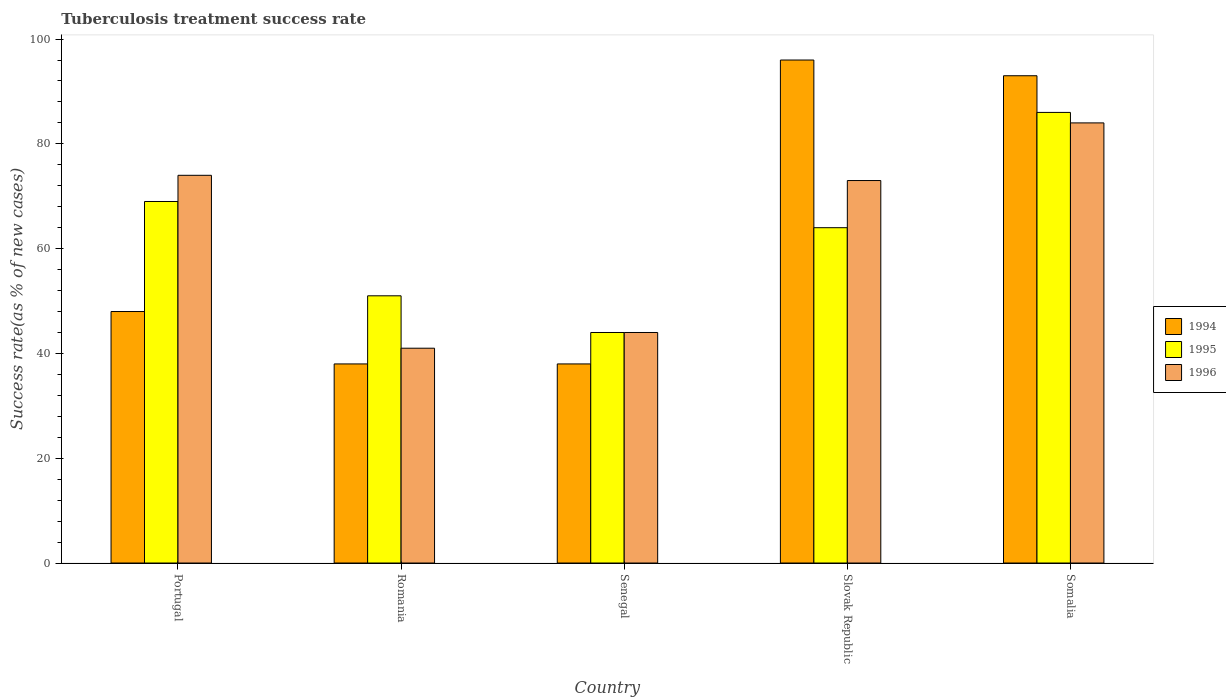What is the label of the 5th group of bars from the left?
Provide a short and direct response. Somalia. Across all countries, what is the maximum tuberculosis treatment success rate in 1994?
Make the answer very short. 96. Across all countries, what is the minimum tuberculosis treatment success rate in 1994?
Your answer should be very brief. 38. In which country was the tuberculosis treatment success rate in 1994 maximum?
Your answer should be compact. Slovak Republic. In which country was the tuberculosis treatment success rate in 1994 minimum?
Keep it short and to the point. Romania. What is the total tuberculosis treatment success rate in 1994 in the graph?
Make the answer very short. 313. What is the average tuberculosis treatment success rate in 1995 per country?
Your answer should be compact. 62.8. What is the difference between the tuberculosis treatment success rate of/in 1995 and tuberculosis treatment success rate of/in 1994 in Slovak Republic?
Offer a terse response. -32. What is the ratio of the tuberculosis treatment success rate in 1995 in Romania to that in Somalia?
Provide a succinct answer. 0.59. Is the tuberculosis treatment success rate in 1996 in Portugal less than that in Senegal?
Provide a short and direct response. No. What is the difference between the highest and the second highest tuberculosis treatment success rate in 1995?
Keep it short and to the point. -5. What is the difference between the highest and the lowest tuberculosis treatment success rate in 1994?
Offer a terse response. 58. Is the sum of the tuberculosis treatment success rate in 1995 in Portugal and Senegal greater than the maximum tuberculosis treatment success rate in 1996 across all countries?
Provide a short and direct response. Yes. What does the 3rd bar from the left in Senegal represents?
Your answer should be compact. 1996. What does the 3rd bar from the right in Romania represents?
Provide a short and direct response. 1994. How many countries are there in the graph?
Give a very brief answer. 5. Does the graph contain any zero values?
Provide a short and direct response. No. Where does the legend appear in the graph?
Provide a succinct answer. Center right. How many legend labels are there?
Provide a short and direct response. 3. What is the title of the graph?
Your response must be concise. Tuberculosis treatment success rate. Does "1968" appear as one of the legend labels in the graph?
Make the answer very short. No. What is the label or title of the X-axis?
Provide a short and direct response. Country. What is the label or title of the Y-axis?
Provide a short and direct response. Success rate(as % of new cases). What is the Success rate(as % of new cases) in 1994 in Portugal?
Provide a succinct answer. 48. What is the Success rate(as % of new cases) of 1994 in Romania?
Your answer should be very brief. 38. What is the Success rate(as % of new cases) of 1996 in Romania?
Your response must be concise. 41. What is the Success rate(as % of new cases) in 1995 in Senegal?
Offer a terse response. 44. What is the Success rate(as % of new cases) in 1996 in Senegal?
Offer a very short reply. 44. What is the Success rate(as % of new cases) in 1994 in Slovak Republic?
Keep it short and to the point. 96. What is the Success rate(as % of new cases) in 1994 in Somalia?
Provide a short and direct response. 93. What is the Success rate(as % of new cases) in 1996 in Somalia?
Provide a succinct answer. 84. Across all countries, what is the maximum Success rate(as % of new cases) of 1994?
Offer a terse response. 96. Across all countries, what is the minimum Success rate(as % of new cases) of 1995?
Give a very brief answer. 44. What is the total Success rate(as % of new cases) in 1994 in the graph?
Offer a very short reply. 313. What is the total Success rate(as % of new cases) in 1995 in the graph?
Give a very brief answer. 314. What is the total Success rate(as % of new cases) in 1996 in the graph?
Offer a very short reply. 316. What is the difference between the Success rate(as % of new cases) of 1994 in Portugal and that in Romania?
Provide a short and direct response. 10. What is the difference between the Success rate(as % of new cases) in 1996 in Portugal and that in Romania?
Make the answer very short. 33. What is the difference between the Success rate(as % of new cases) of 1994 in Portugal and that in Senegal?
Provide a short and direct response. 10. What is the difference between the Success rate(as % of new cases) of 1994 in Portugal and that in Slovak Republic?
Offer a terse response. -48. What is the difference between the Success rate(as % of new cases) in 1995 in Portugal and that in Slovak Republic?
Offer a very short reply. 5. What is the difference between the Success rate(as % of new cases) of 1994 in Portugal and that in Somalia?
Ensure brevity in your answer.  -45. What is the difference between the Success rate(as % of new cases) in 1995 in Portugal and that in Somalia?
Ensure brevity in your answer.  -17. What is the difference between the Success rate(as % of new cases) in 1994 in Romania and that in Senegal?
Provide a succinct answer. 0. What is the difference between the Success rate(as % of new cases) of 1995 in Romania and that in Senegal?
Keep it short and to the point. 7. What is the difference between the Success rate(as % of new cases) in 1994 in Romania and that in Slovak Republic?
Keep it short and to the point. -58. What is the difference between the Success rate(as % of new cases) of 1995 in Romania and that in Slovak Republic?
Your answer should be very brief. -13. What is the difference between the Success rate(as % of new cases) of 1996 in Romania and that in Slovak Republic?
Your response must be concise. -32. What is the difference between the Success rate(as % of new cases) of 1994 in Romania and that in Somalia?
Provide a succinct answer. -55. What is the difference between the Success rate(as % of new cases) of 1995 in Romania and that in Somalia?
Make the answer very short. -35. What is the difference between the Success rate(as % of new cases) of 1996 in Romania and that in Somalia?
Provide a short and direct response. -43. What is the difference between the Success rate(as % of new cases) in 1994 in Senegal and that in Slovak Republic?
Offer a terse response. -58. What is the difference between the Success rate(as % of new cases) in 1995 in Senegal and that in Slovak Republic?
Offer a very short reply. -20. What is the difference between the Success rate(as % of new cases) in 1996 in Senegal and that in Slovak Republic?
Provide a short and direct response. -29. What is the difference between the Success rate(as % of new cases) of 1994 in Senegal and that in Somalia?
Provide a succinct answer. -55. What is the difference between the Success rate(as % of new cases) of 1995 in Senegal and that in Somalia?
Make the answer very short. -42. What is the difference between the Success rate(as % of new cases) of 1996 in Senegal and that in Somalia?
Offer a very short reply. -40. What is the difference between the Success rate(as % of new cases) in 1996 in Slovak Republic and that in Somalia?
Offer a terse response. -11. What is the difference between the Success rate(as % of new cases) of 1994 in Portugal and the Success rate(as % of new cases) of 1995 in Romania?
Your answer should be compact. -3. What is the difference between the Success rate(as % of new cases) in 1994 in Portugal and the Success rate(as % of new cases) in 1995 in Senegal?
Provide a succinct answer. 4. What is the difference between the Success rate(as % of new cases) in 1994 in Portugal and the Success rate(as % of new cases) in 1996 in Senegal?
Your answer should be very brief. 4. What is the difference between the Success rate(as % of new cases) of 1995 in Portugal and the Success rate(as % of new cases) of 1996 in Senegal?
Make the answer very short. 25. What is the difference between the Success rate(as % of new cases) in 1995 in Portugal and the Success rate(as % of new cases) in 1996 in Slovak Republic?
Ensure brevity in your answer.  -4. What is the difference between the Success rate(as % of new cases) in 1994 in Portugal and the Success rate(as % of new cases) in 1995 in Somalia?
Your answer should be very brief. -38. What is the difference between the Success rate(as % of new cases) of 1994 in Portugal and the Success rate(as % of new cases) of 1996 in Somalia?
Provide a succinct answer. -36. What is the difference between the Success rate(as % of new cases) of 1995 in Portugal and the Success rate(as % of new cases) of 1996 in Somalia?
Give a very brief answer. -15. What is the difference between the Success rate(as % of new cases) in 1995 in Romania and the Success rate(as % of new cases) in 1996 in Senegal?
Provide a short and direct response. 7. What is the difference between the Success rate(as % of new cases) in 1994 in Romania and the Success rate(as % of new cases) in 1996 in Slovak Republic?
Ensure brevity in your answer.  -35. What is the difference between the Success rate(as % of new cases) of 1994 in Romania and the Success rate(as % of new cases) of 1995 in Somalia?
Offer a terse response. -48. What is the difference between the Success rate(as % of new cases) of 1994 in Romania and the Success rate(as % of new cases) of 1996 in Somalia?
Offer a very short reply. -46. What is the difference between the Success rate(as % of new cases) of 1995 in Romania and the Success rate(as % of new cases) of 1996 in Somalia?
Your answer should be compact. -33. What is the difference between the Success rate(as % of new cases) of 1994 in Senegal and the Success rate(as % of new cases) of 1996 in Slovak Republic?
Ensure brevity in your answer.  -35. What is the difference between the Success rate(as % of new cases) in 1995 in Senegal and the Success rate(as % of new cases) in 1996 in Slovak Republic?
Give a very brief answer. -29. What is the difference between the Success rate(as % of new cases) of 1994 in Senegal and the Success rate(as % of new cases) of 1995 in Somalia?
Make the answer very short. -48. What is the difference between the Success rate(as % of new cases) of 1994 in Senegal and the Success rate(as % of new cases) of 1996 in Somalia?
Ensure brevity in your answer.  -46. What is the difference between the Success rate(as % of new cases) of 1995 in Senegal and the Success rate(as % of new cases) of 1996 in Somalia?
Offer a terse response. -40. What is the difference between the Success rate(as % of new cases) in 1994 in Slovak Republic and the Success rate(as % of new cases) in 1996 in Somalia?
Your answer should be compact. 12. What is the difference between the Success rate(as % of new cases) of 1995 in Slovak Republic and the Success rate(as % of new cases) of 1996 in Somalia?
Offer a very short reply. -20. What is the average Success rate(as % of new cases) in 1994 per country?
Give a very brief answer. 62.6. What is the average Success rate(as % of new cases) in 1995 per country?
Keep it short and to the point. 62.8. What is the average Success rate(as % of new cases) in 1996 per country?
Your answer should be compact. 63.2. What is the difference between the Success rate(as % of new cases) in 1994 and Success rate(as % of new cases) in 1995 in Portugal?
Provide a succinct answer. -21. What is the difference between the Success rate(as % of new cases) of 1994 and Success rate(as % of new cases) of 1996 in Romania?
Offer a very short reply. -3. What is the difference between the Success rate(as % of new cases) in 1994 and Success rate(as % of new cases) in 1995 in Senegal?
Provide a succinct answer. -6. What is the difference between the Success rate(as % of new cases) of 1994 and Success rate(as % of new cases) of 1996 in Senegal?
Offer a terse response. -6. What is the difference between the Success rate(as % of new cases) in 1994 and Success rate(as % of new cases) in 1995 in Slovak Republic?
Your response must be concise. 32. What is the difference between the Success rate(as % of new cases) of 1995 and Success rate(as % of new cases) of 1996 in Slovak Republic?
Your response must be concise. -9. What is the difference between the Success rate(as % of new cases) of 1994 and Success rate(as % of new cases) of 1995 in Somalia?
Your answer should be compact. 7. What is the difference between the Success rate(as % of new cases) in 1995 and Success rate(as % of new cases) in 1996 in Somalia?
Provide a short and direct response. 2. What is the ratio of the Success rate(as % of new cases) in 1994 in Portugal to that in Romania?
Give a very brief answer. 1.26. What is the ratio of the Success rate(as % of new cases) of 1995 in Portugal to that in Romania?
Your answer should be very brief. 1.35. What is the ratio of the Success rate(as % of new cases) of 1996 in Portugal to that in Romania?
Your response must be concise. 1.8. What is the ratio of the Success rate(as % of new cases) in 1994 in Portugal to that in Senegal?
Your answer should be very brief. 1.26. What is the ratio of the Success rate(as % of new cases) of 1995 in Portugal to that in Senegal?
Keep it short and to the point. 1.57. What is the ratio of the Success rate(as % of new cases) in 1996 in Portugal to that in Senegal?
Your response must be concise. 1.68. What is the ratio of the Success rate(as % of new cases) of 1995 in Portugal to that in Slovak Republic?
Keep it short and to the point. 1.08. What is the ratio of the Success rate(as % of new cases) in 1996 in Portugal to that in Slovak Republic?
Give a very brief answer. 1.01. What is the ratio of the Success rate(as % of new cases) in 1994 in Portugal to that in Somalia?
Offer a terse response. 0.52. What is the ratio of the Success rate(as % of new cases) of 1995 in Portugal to that in Somalia?
Keep it short and to the point. 0.8. What is the ratio of the Success rate(as % of new cases) of 1996 in Portugal to that in Somalia?
Offer a very short reply. 0.88. What is the ratio of the Success rate(as % of new cases) of 1994 in Romania to that in Senegal?
Offer a terse response. 1. What is the ratio of the Success rate(as % of new cases) of 1995 in Romania to that in Senegal?
Offer a terse response. 1.16. What is the ratio of the Success rate(as % of new cases) of 1996 in Romania to that in Senegal?
Your answer should be very brief. 0.93. What is the ratio of the Success rate(as % of new cases) in 1994 in Romania to that in Slovak Republic?
Ensure brevity in your answer.  0.4. What is the ratio of the Success rate(as % of new cases) of 1995 in Romania to that in Slovak Republic?
Provide a succinct answer. 0.8. What is the ratio of the Success rate(as % of new cases) of 1996 in Romania to that in Slovak Republic?
Provide a short and direct response. 0.56. What is the ratio of the Success rate(as % of new cases) of 1994 in Romania to that in Somalia?
Ensure brevity in your answer.  0.41. What is the ratio of the Success rate(as % of new cases) in 1995 in Romania to that in Somalia?
Offer a terse response. 0.59. What is the ratio of the Success rate(as % of new cases) of 1996 in Romania to that in Somalia?
Provide a short and direct response. 0.49. What is the ratio of the Success rate(as % of new cases) in 1994 in Senegal to that in Slovak Republic?
Your response must be concise. 0.4. What is the ratio of the Success rate(as % of new cases) in 1995 in Senegal to that in Slovak Republic?
Ensure brevity in your answer.  0.69. What is the ratio of the Success rate(as % of new cases) of 1996 in Senegal to that in Slovak Republic?
Make the answer very short. 0.6. What is the ratio of the Success rate(as % of new cases) in 1994 in Senegal to that in Somalia?
Give a very brief answer. 0.41. What is the ratio of the Success rate(as % of new cases) of 1995 in Senegal to that in Somalia?
Offer a very short reply. 0.51. What is the ratio of the Success rate(as % of new cases) in 1996 in Senegal to that in Somalia?
Your answer should be compact. 0.52. What is the ratio of the Success rate(as % of new cases) of 1994 in Slovak Republic to that in Somalia?
Ensure brevity in your answer.  1.03. What is the ratio of the Success rate(as % of new cases) in 1995 in Slovak Republic to that in Somalia?
Your answer should be very brief. 0.74. What is the ratio of the Success rate(as % of new cases) of 1996 in Slovak Republic to that in Somalia?
Your response must be concise. 0.87. What is the difference between the highest and the second highest Success rate(as % of new cases) in 1994?
Your response must be concise. 3. What is the difference between the highest and the second highest Success rate(as % of new cases) in 1995?
Provide a short and direct response. 17. What is the difference between the highest and the second highest Success rate(as % of new cases) in 1996?
Keep it short and to the point. 10. What is the difference between the highest and the lowest Success rate(as % of new cases) of 1994?
Your response must be concise. 58. What is the difference between the highest and the lowest Success rate(as % of new cases) in 1996?
Make the answer very short. 43. 